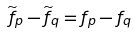Convert formula to latex. <formula><loc_0><loc_0><loc_500><loc_500>\widetilde { f } _ { p } - \widetilde { f } _ { q } = f _ { p } - f _ { q }</formula> 